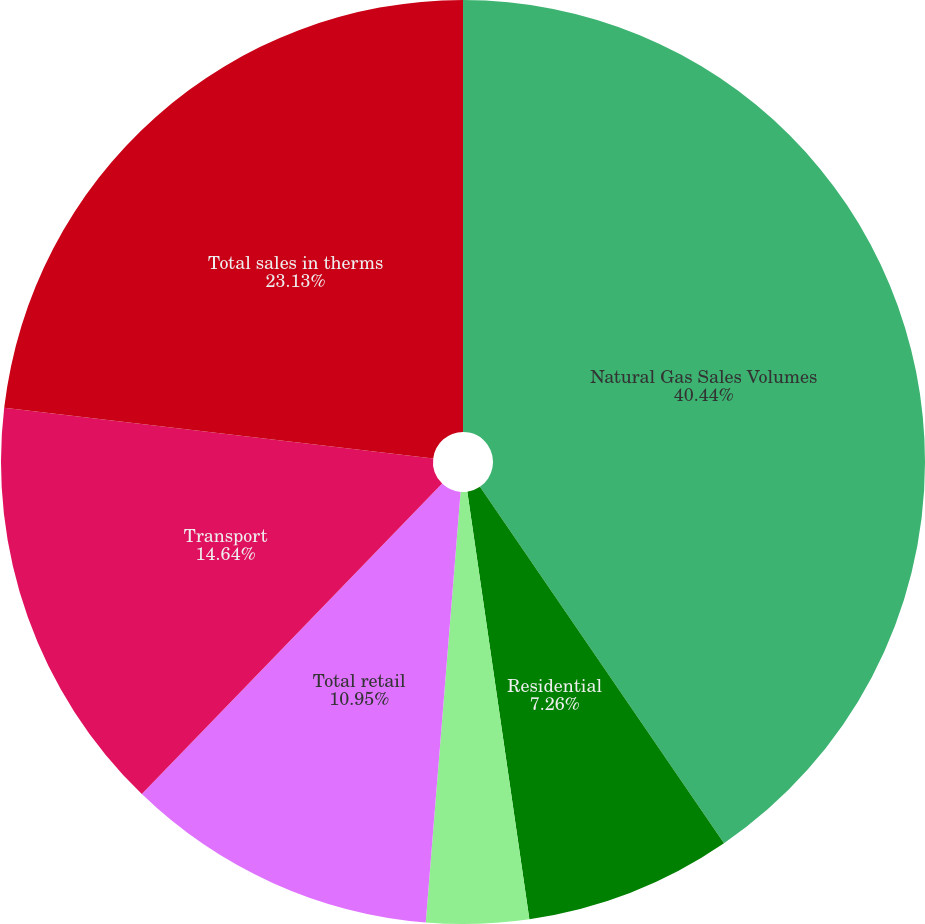Convert chart to OTSL. <chart><loc_0><loc_0><loc_500><loc_500><pie_chart><fcel>Natural Gas Sales Volumes<fcel>Residential<fcel>Commercial and industrial<fcel>Total retail<fcel>Transport<fcel>Total sales in therms<nl><fcel>40.45%<fcel>7.26%<fcel>3.58%<fcel>10.95%<fcel>14.64%<fcel>23.13%<nl></chart> 